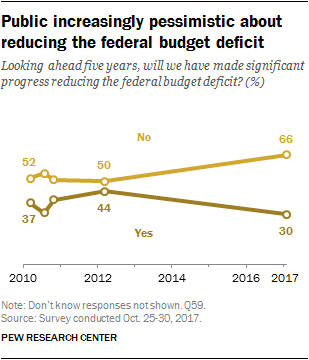Highlight a few significant elements in this photo. The latest year value in the No category is 66.. The average score for the "Yes" category is 37 out of 50. 